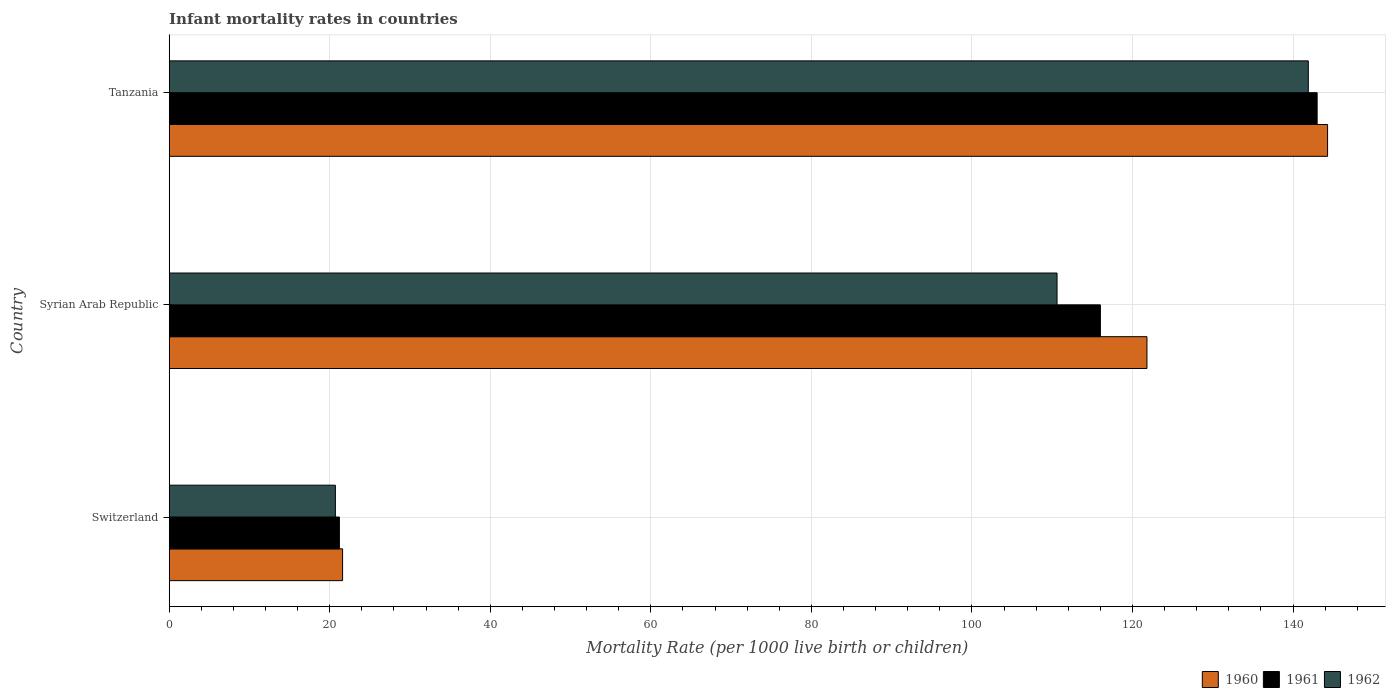How many different coloured bars are there?
Offer a very short reply. 3. Are the number of bars per tick equal to the number of legend labels?
Make the answer very short. Yes. How many bars are there on the 3rd tick from the top?
Give a very brief answer. 3. How many bars are there on the 1st tick from the bottom?
Offer a very short reply. 3. What is the label of the 1st group of bars from the top?
Offer a very short reply. Tanzania. What is the infant mortality rate in 1961 in Tanzania?
Your answer should be compact. 143. Across all countries, what is the maximum infant mortality rate in 1962?
Keep it short and to the point. 141.9. Across all countries, what is the minimum infant mortality rate in 1962?
Offer a very short reply. 20.7. In which country was the infant mortality rate in 1961 maximum?
Offer a terse response. Tanzania. In which country was the infant mortality rate in 1961 minimum?
Provide a short and direct response. Switzerland. What is the total infant mortality rate in 1962 in the graph?
Offer a terse response. 273.2. What is the difference between the infant mortality rate in 1960 in Switzerland and the infant mortality rate in 1962 in Syrian Arab Republic?
Your answer should be very brief. -89. What is the average infant mortality rate in 1962 per country?
Provide a succinct answer. 91.07. What is the ratio of the infant mortality rate in 1961 in Syrian Arab Republic to that in Tanzania?
Ensure brevity in your answer.  0.81. Is the infant mortality rate in 1961 in Switzerland less than that in Syrian Arab Republic?
Offer a very short reply. Yes. What is the difference between the highest and the second highest infant mortality rate in 1961?
Keep it short and to the point. 27. What is the difference between the highest and the lowest infant mortality rate in 1961?
Your answer should be compact. 121.8. What does the 2nd bar from the bottom in Switzerland represents?
Make the answer very short. 1961. How many bars are there?
Offer a terse response. 9. Are all the bars in the graph horizontal?
Offer a very short reply. Yes. Does the graph contain any zero values?
Make the answer very short. No. What is the title of the graph?
Offer a terse response. Infant mortality rates in countries. Does "2009" appear as one of the legend labels in the graph?
Your answer should be very brief. No. What is the label or title of the X-axis?
Offer a very short reply. Mortality Rate (per 1000 live birth or children). What is the Mortality Rate (per 1000 live birth or children) in 1960 in Switzerland?
Provide a short and direct response. 21.6. What is the Mortality Rate (per 1000 live birth or children) in 1961 in Switzerland?
Make the answer very short. 21.2. What is the Mortality Rate (per 1000 live birth or children) of 1962 in Switzerland?
Keep it short and to the point. 20.7. What is the Mortality Rate (per 1000 live birth or children) in 1960 in Syrian Arab Republic?
Give a very brief answer. 121.8. What is the Mortality Rate (per 1000 live birth or children) of 1961 in Syrian Arab Republic?
Offer a terse response. 116. What is the Mortality Rate (per 1000 live birth or children) in 1962 in Syrian Arab Republic?
Give a very brief answer. 110.6. What is the Mortality Rate (per 1000 live birth or children) of 1960 in Tanzania?
Your answer should be very brief. 144.3. What is the Mortality Rate (per 1000 live birth or children) in 1961 in Tanzania?
Your response must be concise. 143. What is the Mortality Rate (per 1000 live birth or children) in 1962 in Tanzania?
Keep it short and to the point. 141.9. Across all countries, what is the maximum Mortality Rate (per 1000 live birth or children) of 1960?
Ensure brevity in your answer.  144.3. Across all countries, what is the maximum Mortality Rate (per 1000 live birth or children) of 1961?
Keep it short and to the point. 143. Across all countries, what is the maximum Mortality Rate (per 1000 live birth or children) of 1962?
Keep it short and to the point. 141.9. Across all countries, what is the minimum Mortality Rate (per 1000 live birth or children) of 1960?
Keep it short and to the point. 21.6. Across all countries, what is the minimum Mortality Rate (per 1000 live birth or children) in 1961?
Offer a terse response. 21.2. Across all countries, what is the minimum Mortality Rate (per 1000 live birth or children) in 1962?
Your answer should be very brief. 20.7. What is the total Mortality Rate (per 1000 live birth or children) in 1960 in the graph?
Keep it short and to the point. 287.7. What is the total Mortality Rate (per 1000 live birth or children) in 1961 in the graph?
Your response must be concise. 280.2. What is the total Mortality Rate (per 1000 live birth or children) in 1962 in the graph?
Your answer should be very brief. 273.2. What is the difference between the Mortality Rate (per 1000 live birth or children) in 1960 in Switzerland and that in Syrian Arab Republic?
Your response must be concise. -100.2. What is the difference between the Mortality Rate (per 1000 live birth or children) of 1961 in Switzerland and that in Syrian Arab Republic?
Offer a terse response. -94.8. What is the difference between the Mortality Rate (per 1000 live birth or children) in 1962 in Switzerland and that in Syrian Arab Republic?
Give a very brief answer. -89.9. What is the difference between the Mortality Rate (per 1000 live birth or children) of 1960 in Switzerland and that in Tanzania?
Your answer should be compact. -122.7. What is the difference between the Mortality Rate (per 1000 live birth or children) of 1961 in Switzerland and that in Tanzania?
Ensure brevity in your answer.  -121.8. What is the difference between the Mortality Rate (per 1000 live birth or children) in 1962 in Switzerland and that in Tanzania?
Give a very brief answer. -121.2. What is the difference between the Mortality Rate (per 1000 live birth or children) of 1960 in Syrian Arab Republic and that in Tanzania?
Offer a very short reply. -22.5. What is the difference between the Mortality Rate (per 1000 live birth or children) in 1962 in Syrian Arab Republic and that in Tanzania?
Give a very brief answer. -31.3. What is the difference between the Mortality Rate (per 1000 live birth or children) in 1960 in Switzerland and the Mortality Rate (per 1000 live birth or children) in 1961 in Syrian Arab Republic?
Provide a short and direct response. -94.4. What is the difference between the Mortality Rate (per 1000 live birth or children) in 1960 in Switzerland and the Mortality Rate (per 1000 live birth or children) in 1962 in Syrian Arab Republic?
Keep it short and to the point. -89. What is the difference between the Mortality Rate (per 1000 live birth or children) of 1961 in Switzerland and the Mortality Rate (per 1000 live birth or children) of 1962 in Syrian Arab Republic?
Offer a very short reply. -89.4. What is the difference between the Mortality Rate (per 1000 live birth or children) of 1960 in Switzerland and the Mortality Rate (per 1000 live birth or children) of 1961 in Tanzania?
Provide a succinct answer. -121.4. What is the difference between the Mortality Rate (per 1000 live birth or children) of 1960 in Switzerland and the Mortality Rate (per 1000 live birth or children) of 1962 in Tanzania?
Ensure brevity in your answer.  -120.3. What is the difference between the Mortality Rate (per 1000 live birth or children) in 1961 in Switzerland and the Mortality Rate (per 1000 live birth or children) in 1962 in Tanzania?
Your answer should be very brief. -120.7. What is the difference between the Mortality Rate (per 1000 live birth or children) in 1960 in Syrian Arab Republic and the Mortality Rate (per 1000 live birth or children) in 1961 in Tanzania?
Provide a short and direct response. -21.2. What is the difference between the Mortality Rate (per 1000 live birth or children) of 1960 in Syrian Arab Republic and the Mortality Rate (per 1000 live birth or children) of 1962 in Tanzania?
Give a very brief answer. -20.1. What is the difference between the Mortality Rate (per 1000 live birth or children) of 1961 in Syrian Arab Republic and the Mortality Rate (per 1000 live birth or children) of 1962 in Tanzania?
Keep it short and to the point. -25.9. What is the average Mortality Rate (per 1000 live birth or children) in 1960 per country?
Give a very brief answer. 95.9. What is the average Mortality Rate (per 1000 live birth or children) of 1961 per country?
Give a very brief answer. 93.4. What is the average Mortality Rate (per 1000 live birth or children) of 1962 per country?
Offer a very short reply. 91.07. What is the difference between the Mortality Rate (per 1000 live birth or children) in 1960 and Mortality Rate (per 1000 live birth or children) in 1961 in Switzerland?
Your response must be concise. 0.4. What is the difference between the Mortality Rate (per 1000 live birth or children) of 1961 and Mortality Rate (per 1000 live birth or children) of 1962 in Switzerland?
Your answer should be very brief. 0.5. What is the difference between the Mortality Rate (per 1000 live birth or children) of 1961 and Mortality Rate (per 1000 live birth or children) of 1962 in Syrian Arab Republic?
Your response must be concise. 5.4. What is the difference between the Mortality Rate (per 1000 live birth or children) in 1960 and Mortality Rate (per 1000 live birth or children) in 1961 in Tanzania?
Offer a very short reply. 1.3. What is the difference between the Mortality Rate (per 1000 live birth or children) of 1961 and Mortality Rate (per 1000 live birth or children) of 1962 in Tanzania?
Keep it short and to the point. 1.1. What is the ratio of the Mortality Rate (per 1000 live birth or children) of 1960 in Switzerland to that in Syrian Arab Republic?
Your answer should be compact. 0.18. What is the ratio of the Mortality Rate (per 1000 live birth or children) in 1961 in Switzerland to that in Syrian Arab Republic?
Your answer should be compact. 0.18. What is the ratio of the Mortality Rate (per 1000 live birth or children) in 1962 in Switzerland to that in Syrian Arab Republic?
Provide a short and direct response. 0.19. What is the ratio of the Mortality Rate (per 1000 live birth or children) in 1960 in Switzerland to that in Tanzania?
Your answer should be compact. 0.15. What is the ratio of the Mortality Rate (per 1000 live birth or children) in 1961 in Switzerland to that in Tanzania?
Keep it short and to the point. 0.15. What is the ratio of the Mortality Rate (per 1000 live birth or children) in 1962 in Switzerland to that in Tanzania?
Provide a short and direct response. 0.15. What is the ratio of the Mortality Rate (per 1000 live birth or children) of 1960 in Syrian Arab Republic to that in Tanzania?
Your response must be concise. 0.84. What is the ratio of the Mortality Rate (per 1000 live birth or children) of 1961 in Syrian Arab Republic to that in Tanzania?
Your answer should be compact. 0.81. What is the ratio of the Mortality Rate (per 1000 live birth or children) of 1962 in Syrian Arab Republic to that in Tanzania?
Offer a very short reply. 0.78. What is the difference between the highest and the second highest Mortality Rate (per 1000 live birth or children) in 1962?
Keep it short and to the point. 31.3. What is the difference between the highest and the lowest Mortality Rate (per 1000 live birth or children) in 1960?
Your answer should be compact. 122.7. What is the difference between the highest and the lowest Mortality Rate (per 1000 live birth or children) in 1961?
Offer a very short reply. 121.8. What is the difference between the highest and the lowest Mortality Rate (per 1000 live birth or children) of 1962?
Make the answer very short. 121.2. 